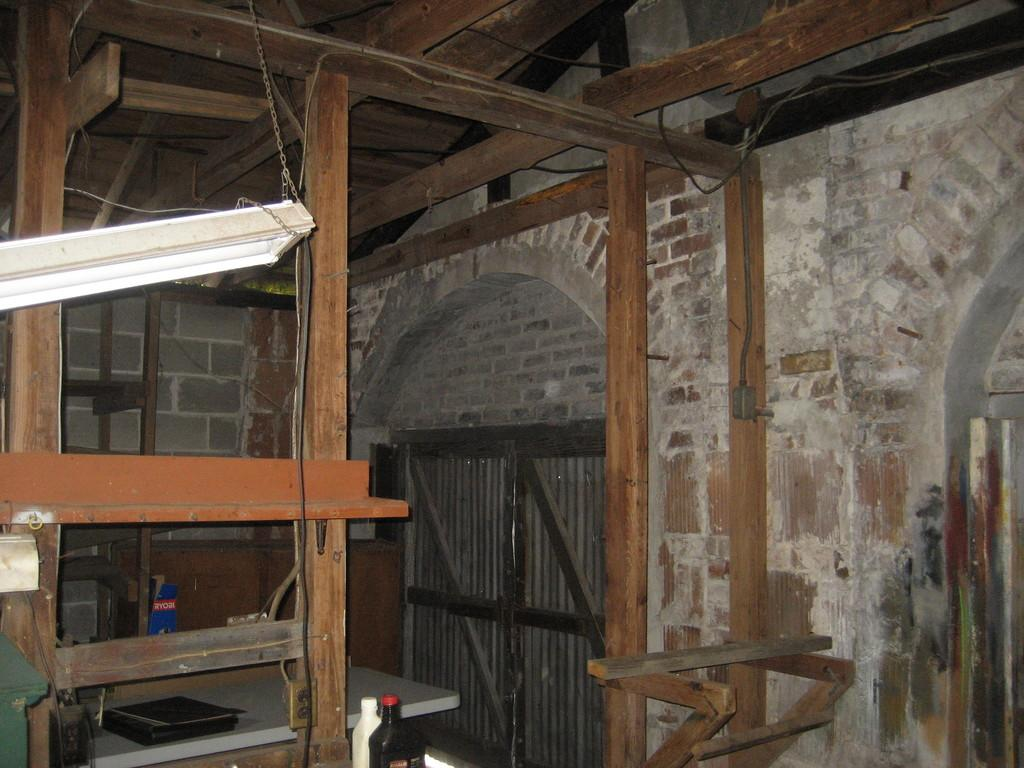What type of furniture is present in the image? The image contains a table. What is placed on the table? There are files on the table. What else can be seen in the image besides the table and files? There are bottles and wood visible in the image. What can be seen in the background of the image? There is a wall and a door in the background of the image. How many combs are used to organize the files on the table? There are no combs present in the image, and the files are not organized with combs. 